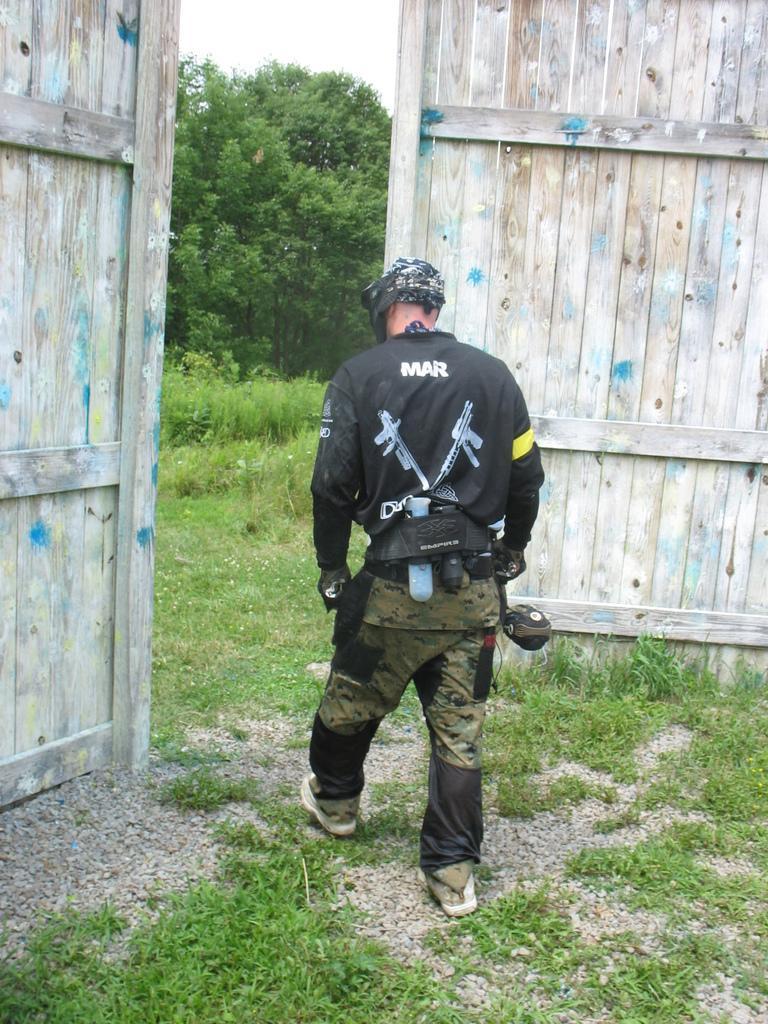Please provide a concise description of this image. In this picture there is a man walking and there is text on the shirt and there are wooden doors and there are trees. At the top there is sky. At the bottom there are plants and stones on the ground. 